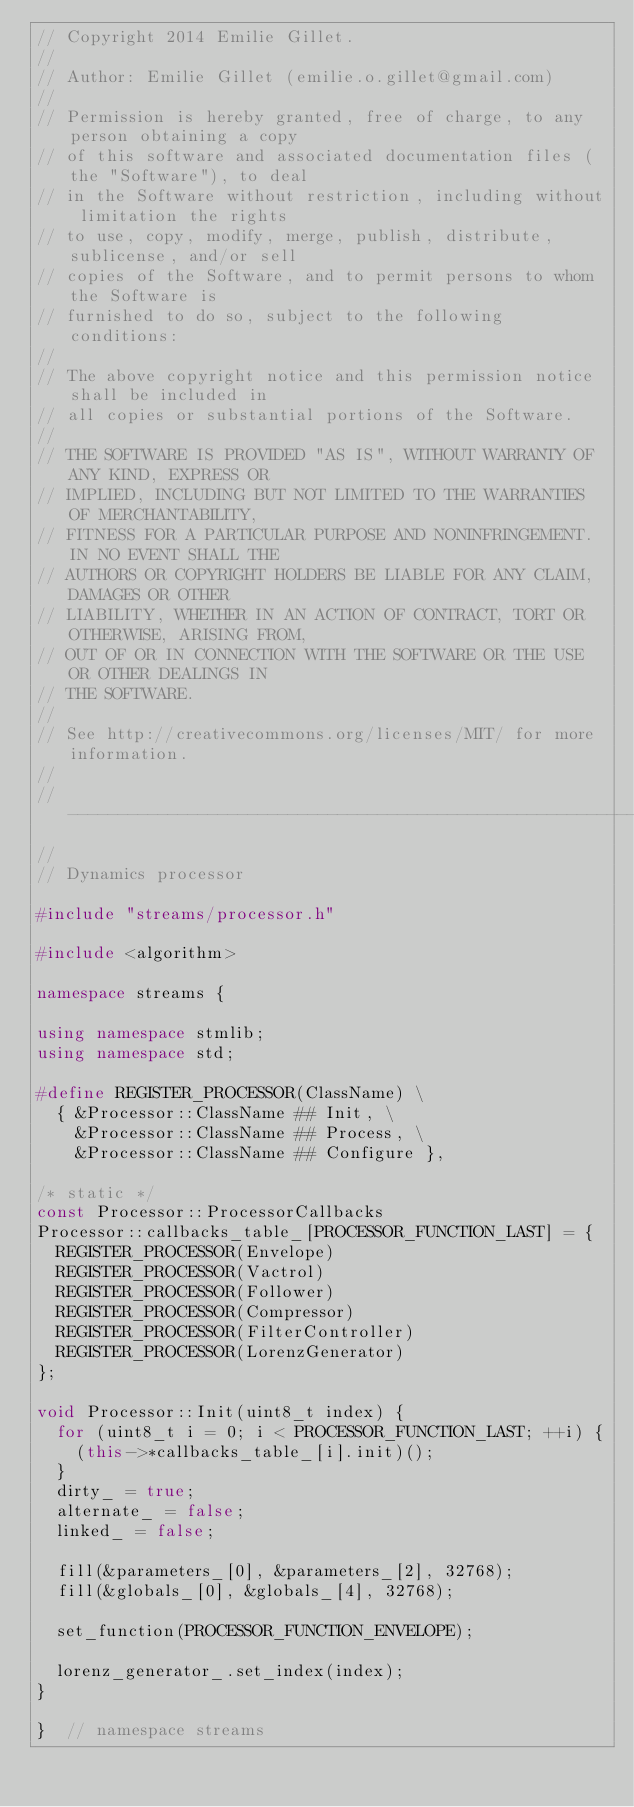Convert code to text. <code><loc_0><loc_0><loc_500><loc_500><_C++_>// Copyright 2014 Emilie Gillet.
//
// Author: Emilie Gillet (emilie.o.gillet@gmail.com)
//
// Permission is hereby granted, free of charge, to any person obtaining a copy
// of this software and associated documentation files (the "Software"), to deal
// in the Software without restriction, including without limitation the rights
// to use, copy, modify, merge, publish, distribute, sublicense, and/or sell
// copies of the Software, and to permit persons to whom the Software is
// furnished to do so, subject to the following conditions:
// 
// The above copyright notice and this permission notice shall be included in
// all copies or substantial portions of the Software.
// 
// THE SOFTWARE IS PROVIDED "AS IS", WITHOUT WARRANTY OF ANY KIND, EXPRESS OR
// IMPLIED, INCLUDING BUT NOT LIMITED TO THE WARRANTIES OF MERCHANTABILITY,
// FITNESS FOR A PARTICULAR PURPOSE AND NONINFRINGEMENT. IN NO EVENT SHALL THE
// AUTHORS OR COPYRIGHT HOLDERS BE LIABLE FOR ANY CLAIM, DAMAGES OR OTHER
// LIABILITY, WHETHER IN AN ACTION OF CONTRACT, TORT OR OTHERWISE, ARISING FROM,
// OUT OF OR IN CONNECTION WITH THE SOFTWARE OR THE USE OR OTHER DEALINGS IN
// THE SOFTWARE.
// 
// See http://creativecommons.org/licenses/MIT/ for more information.
//
// -----------------------------------------------------------------------------
//
// Dynamics processor

#include "streams/processor.h"

#include <algorithm>

namespace streams {

using namespace stmlib;
using namespace std;

#define REGISTER_PROCESSOR(ClassName) \
  { &Processor::ClassName ## Init, \
    &Processor::ClassName ## Process, \
    &Processor::ClassName ## Configure },

/* static */
const Processor::ProcessorCallbacks 
Processor::callbacks_table_[PROCESSOR_FUNCTION_LAST] = {
  REGISTER_PROCESSOR(Envelope)
  REGISTER_PROCESSOR(Vactrol)
  REGISTER_PROCESSOR(Follower)
  REGISTER_PROCESSOR(Compressor)
  REGISTER_PROCESSOR(FilterController)
  REGISTER_PROCESSOR(LorenzGenerator)
};

void Processor::Init(uint8_t index) {
  for (uint8_t i = 0; i < PROCESSOR_FUNCTION_LAST; ++i) {
    (this->*callbacks_table_[i].init)();
  }
  dirty_ = true;
  alternate_ = false;
  linked_ = false;
  
  fill(&parameters_[0], &parameters_[2], 32768);
  fill(&globals_[0], &globals_[4], 32768);
  
  set_function(PROCESSOR_FUNCTION_ENVELOPE);
  
  lorenz_generator_.set_index(index);
}

}  // namespace streams
</code> 